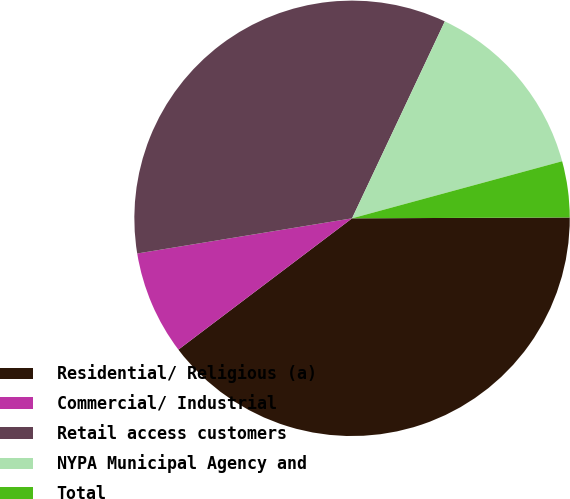Convert chart to OTSL. <chart><loc_0><loc_0><loc_500><loc_500><pie_chart><fcel>Residential/ Religious (a)<fcel>Commercial/ Industrial<fcel>Retail access customers<fcel>NYPA Municipal Agency and<fcel>Total<nl><fcel>39.76%<fcel>7.72%<fcel>34.59%<fcel>13.77%<fcel>4.16%<nl></chart> 